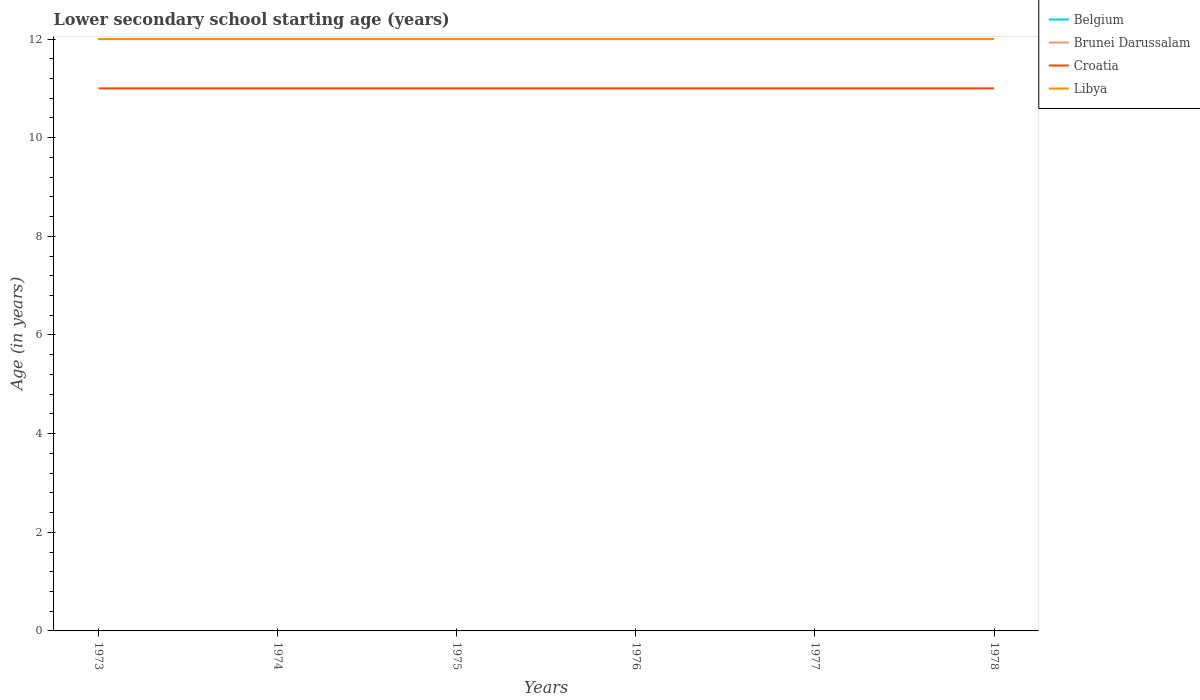Across all years, what is the maximum lower secondary school starting age of children in Belgium?
Your answer should be compact. 12. In which year was the lower secondary school starting age of children in Croatia maximum?
Your answer should be very brief. 1973. What is the total lower secondary school starting age of children in Brunei Darussalam in the graph?
Your answer should be very brief. 0. Is the lower secondary school starting age of children in Brunei Darussalam strictly greater than the lower secondary school starting age of children in Croatia over the years?
Your answer should be very brief. No. Are the values on the major ticks of Y-axis written in scientific E-notation?
Keep it short and to the point. No. Does the graph contain grids?
Provide a succinct answer. No. What is the title of the graph?
Give a very brief answer. Lower secondary school starting age (years). What is the label or title of the X-axis?
Provide a short and direct response. Years. What is the label or title of the Y-axis?
Your answer should be very brief. Age (in years). What is the Age (in years) in Libya in 1973?
Your answer should be very brief. 12. What is the Age (in years) in Belgium in 1975?
Your answer should be compact. 12. What is the Age (in years) of Croatia in 1975?
Your answer should be compact. 11. What is the Age (in years) of Libya in 1975?
Offer a terse response. 12. What is the Age (in years) of Belgium in 1976?
Offer a very short reply. 12. What is the Age (in years) of Libya in 1976?
Give a very brief answer. 12. What is the Age (in years) in Brunei Darussalam in 1977?
Provide a succinct answer. 12. What is the Age (in years) of Croatia in 1977?
Provide a succinct answer. 11. What is the Age (in years) in Brunei Darussalam in 1978?
Make the answer very short. 12. What is the Age (in years) of Croatia in 1978?
Your answer should be very brief. 11. Across all years, what is the maximum Age (in years) of Brunei Darussalam?
Provide a succinct answer. 12. Across all years, what is the minimum Age (in years) in Belgium?
Keep it short and to the point. 12. Across all years, what is the minimum Age (in years) of Brunei Darussalam?
Offer a very short reply. 12. Across all years, what is the minimum Age (in years) in Croatia?
Provide a short and direct response. 11. Across all years, what is the minimum Age (in years) in Libya?
Offer a very short reply. 12. What is the total Age (in years) in Belgium in the graph?
Offer a very short reply. 72. What is the total Age (in years) of Croatia in the graph?
Your answer should be compact. 66. What is the total Age (in years) in Libya in the graph?
Give a very brief answer. 72. What is the difference between the Age (in years) of Belgium in 1973 and that in 1974?
Provide a succinct answer. 0. What is the difference between the Age (in years) in Croatia in 1973 and that in 1974?
Keep it short and to the point. 0. What is the difference between the Age (in years) in Libya in 1973 and that in 1974?
Provide a short and direct response. 0. What is the difference between the Age (in years) of Belgium in 1973 and that in 1975?
Ensure brevity in your answer.  0. What is the difference between the Age (in years) of Croatia in 1973 and that in 1975?
Give a very brief answer. 0. What is the difference between the Age (in years) of Libya in 1973 and that in 1975?
Offer a very short reply. 0. What is the difference between the Age (in years) in Brunei Darussalam in 1973 and that in 1976?
Keep it short and to the point. 0. What is the difference between the Age (in years) of Croatia in 1973 and that in 1976?
Offer a very short reply. 0. What is the difference between the Age (in years) in Libya in 1973 and that in 1976?
Your response must be concise. 0. What is the difference between the Age (in years) of Brunei Darussalam in 1973 and that in 1977?
Keep it short and to the point. 0. What is the difference between the Age (in years) of Croatia in 1973 and that in 1977?
Offer a terse response. 0. What is the difference between the Age (in years) of Brunei Darussalam in 1973 and that in 1978?
Give a very brief answer. 0. What is the difference between the Age (in years) in Croatia in 1973 and that in 1978?
Your answer should be compact. 0. What is the difference between the Age (in years) in Libya in 1973 and that in 1978?
Provide a succinct answer. 0. What is the difference between the Age (in years) of Belgium in 1974 and that in 1975?
Give a very brief answer. 0. What is the difference between the Age (in years) in Croatia in 1974 and that in 1975?
Offer a very short reply. 0. What is the difference between the Age (in years) of Libya in 1974 and that in 1975?
Offer a terse response. 0. What is the difference between the Age (in years) in Belgium in 1974 and that in 1976?
Ensure brevity in your answer.  0. What is the difference between the Age (in years) in Brunei Darussalam in 1974 and that in 1976?
Your answer should be compact. 0. What is the difference between the Age (in years) in Libya in 1974 and that in 1976?
Your answer should be very brief. 0. What is the difference between the Age (in years) in Belgium in 1974 and that in 1977?
Your answer should be compact. 0. What is the difference between the Age (in years) in Libya in 1974 and that in 1977?
Offer a terse response. 0. What is the difference between the Age (in years) of Belgium in 1974 and that in 1978?
Ensure brevity in your answer.  0. What is the difference between the Age (in years) in Libya in 1974 and that in 1978?
Ensure brevity in your answer.  0. What is the difference between the Age (in years) in Belgium in 1975 and that in 1976?
Make the answer very short. 0. What is the difference between the Age (in years) of Brunei Darussalam in 1975 and that in 1976?
Offer a very short reply. 0. What is the difference between the Age (in years) of Croatia in 1975 and that in 1976?
Offer a very short reply. 0. What is the difference between the Age (in years) of Libya in 1975 and that in 1976?
Your answer should be very brief. 0. What is the difference between the Age (in years) of Brunei Darussalam in 1975 and that in 1977?
Offer a very short reply. 0. What is the difference between the Age (in years) of Croatia in 1975 and that in 1977?
Your answer should be compact. 0. What is the difference between the Age (in years) of Libya in 1975 and that in 1977?
Your answer should be compact. 0. What is the difference between the Age (in years) in Croatia in 1975 and that in 1978?
Your response must be concise. 0. What is the difference between the Age (in years) in Libya in 1975 and that in 1978?
Provide a succinct answer. 0. What is the difference between the Age (in years) in Brunei Darussalam in 1976 and that in 1977?
Keep it short and to the point. 0. What is the difference between the Age (in years) of Belgium in 1976 and that in 1978?
Offer a very short reply. 0. What is the difference between the Age (in years) of Croatia in 1976 and that in 1978?
Provide a succinct answer. 0. What is the difference between the Age (in years) of Libya in 1976 and that in 1978?
Your answer should be compact. 0. What is the difference between the Age (in years) in Brunei Darussalam in 1977 and that in 1978?
Your answer should be very brief. 0. What is the difference between the Age (in years) in Croatia in 1977 and that in 1978?
Offer a very short reply. 0. What is the difference between the Age (in years) in Libya in 1977 and that in 1978?
Keep it short and to the point. 0. What is the difference between the Age (in years) of Belgium in 1973 and the Age (in years) of Croatia in 1974?
Keep it short and to the point. 1. What is the difference between the Age (in years) in Belgium in 1973 and the Age (in years) in Libya in 1974?
Make the answer very short. 0. What is the difference between the Age (in years) of Belgium in 1973 and the Age (in years) of Croatia in 1975?
Your answer should be very brief. 1. What is the difference between the Age (in years) in Brunei Darussalam in 1973 and the Age (in years) in Croatia in 1975?
Ensure brevity in your answer.  1. What is the difference between the Age (in years) of Brunei Darussalam in 1973 and the Age (in years) of Libya in 1975?
Your answer should be very brief. 0. What is the difference between the Age (in years) in Croatia in 1973 and the Age (in years) in Libya in 1975?
Make the answer very short. -1. What is the difference between the Age (in years) in Belgium in 1973 and the Age (in years) in Croatia in 1976?
Offer a terse response. 1. What is the difference between the Age (in years) in Belgium in 1973 and the Age (in years) in Libya in 1976?
Give a very brief answer. 0. What is the difference between the Age (in years) of Brunei Darussalam in 1973 and the Age (in years) of Croatia in 1976?
Ensure brevity in your answer.  1. What is the difference between the Age (in years) of Brunei Darussalam in 1973 and the Age (in years) of Libya in 1977?
Provide a succinct answer. 0. What is the difference between the Age (in years) of Belgium in 1973 and the Age (in years) of Croatia in 1978?
Your answer should be compact. 1. What is the difference between the Age (in years) in Brunei Darussalam in 1973 and the Age (in years) in Croatia in 1978?
Give a very brief answer. 1. What is the difference between the Age (in years) in Brunei Darussalam in 1973 and the Age (in years) in Libya in 1978?
Your answer should be very brief. 0. What is the difference between the Age (in years) of Belgium in 1974 and the Age (in years) of Brunei Darussalam in 1975?
Provide a short and direct response. 0. What is the difference between the Age (in years) in Brunei Darussalam in 1974 and the Age (in years) in Croatia in 1975?
Your answer should be very brief. 1. What is the difference between the Age (in years) of Brunei Darussalam in 1974 and the Age (in years) of Libya in 1975?
Your answer should be compact. 0. What is the difference between the Age (in years) of Croatia in 1974 and the Age (in years) of Libya in 1975?
Keep it short and to the point. -1. What is the difference between the Age (in years) of Belgium in 1974 and the Age (in years) of Libya in 1976?
Give a very brief answer. 0. What is the difference between the Age (in years) in Brunei Darussalam in 1974 and the Age (in years) in Croatia in 1976?
Offer a terse response. 1. What is the difference between the Age (in years) in Belgium in 1974 and the Age (in years) in Brunei Darussalam in 1977?
Your answer should be compact. 0. What is the difference between the Age (in years) of Belgium in 1974 and the Age (in years) of Libya in 1977?
Provide a succinct answer. 0. What is the difference between the Age (in years) of Croatia in 1974 and the Age (in years) of Libya in 1977?
Give a very brief answer. -1. What is the difference between the Age (in years) in Belgium in 1974 and the Age (in years) in Brunei Darussalam in 1978?
Your answer should be compact. 0. What is the difference between the Age (in years) in Belgium in 1974 and the Age (in years) in Libya in 1978?
Make the answer very short. 0. What is the difference between the Age (in years) of Brunei Darussalam in 1974 and the Age (in years) of Libya in 1978?
Offer a terse response. 0. What is the difference between the Age (in years) of Belgium in 1975 and the Age (in years) of Brunei Darussalam in 1976?
Your answer should be very brief. 0. What is the difference between the Age (in years) of Belgium in 1975 and the Age (in years) of Croatia in 1976?
Offer a terse response. 1. What is the difference between the Age (in years) of Brunei Darussalam in 1975 and the Age (in years) of Croatia in 1976?
Keep it short and to the point. 1. What is the difference between the Age (in years) of Brunei Darussalam in 1975 and the Age (in years) of Libya in 1976?
Give a very brief answer. 0. What is the difference between the Age (in years) in Croatia in 1975 and the Age (in years) in Libya in 1976?
Provide a succinct answer. -1. What is the difference between the Age (in years) in Brunei Darussalam in 1975 and the Age (in years) in Libya in 1977?
Your answer should be very brief. 0. What is the difference between the Age (in years) of Croatia in 1975 and the Age (in years) of Libya in 1977?
Keep it short and to the point. -1. What is the difference between the Age (in years) in Belgium in 1975 and the Age (in years) in Libya in 1978?
Make the answer very short. 0. What is the difference between the Age (in years) of Brunei Darussalam in 1975 and the Age (in years) of Libya in 1978?
Provide a succinct answer. 0. What is the difference between the Age (in years) in Croatia in 1975 and the Age (in years) in Libya in 1978?
Give a very brief answer. -1. What is the difference between the Age (in years) in Belgium in 1976 and the Age (in years) in Brunei Darussalam in 1977?
Provide a succinct answer. 0. What is the difference between the Age (in years) in Belgium in 1976 and the Age (in years) in Libya in 1977?
Offer a terse response. 0. What is the difference between the Age (in years) of Belgium in 1976 and the Age (in years) of Brunei Darussalam in 1978?
Offer a terse response. 0. What is the difference between the Age (in years) of Croatia in 1977 and the Age (in years) of Libya in 1978?
Ensure brevity in your answer.  -1. What is the average Age (in years) in Brunei Darussalam per year?
Provide a short and direct response. 12. What is the average Age (in years) of Croatia per year?
Make the answer very short. 11. What is the average Age (in years) of Libya per year?
Give a very brief answer. 12. In the year 1973, what is the difference between the Age (in years) of Belgium and Age (in years) of Libya?
Provide a succinct answer. 0. In the year 1973, what is the difference between the Age (in years) of Brunei Darussalam and Age (in years) of Croatia?
Offer a very short reply. 1. In the year 1973, what is the difference between the Age (in years) of Brunei Darussalam and Age (in years) of Libya?
Your response must be concise. 0. In the year 1974, what is the difference between the Age (in years) of Belgium and Age (in years) of Croatia?
Provide a succinct answer. 1. In the year 1974, what is the difference between the Age (in years) in Belgium and Age (in years) in Libya?
Offer a very short reply. 0. In the year 1974, what is the difference between the Age (in years) in Brunei Darussalam and Age (in years) in Libya?
Your answer should be compact. 0. In the year 1974, what is the difference between the Age (in years) in Croatia and Age (in years) in Libya?
Ensure brevity in your answer.  -1. In the year 1975, what is the difference between the Age (in years) in Belgium and Age (in years) in Croatia?
Keep it short and to the point. 1. In the year 1976, what is the difference between the Age (in years) of Belgium and Age (in years) of Brunei Darussalam?
Provide a short and direct response. 0. In the year 1976, what is the difference between the Age (in years) in Belgium and Age (in years) in Croatia?
Your answer should be very brief. 1. In the year 1977, what is the difference between the Age (in years) in Belgium and Age (in years) in Brunei Darussalam?
Provide a succinct answer. 0. In the year 1977, what is the difference between the Age (in years) in Brunei Darussalam and Age (in years) in Croatia?
Ensure brevity in your answer.  1. In the year 1977, what is the difference between the Age (in years) in Brunei Darussalam and Age (in years) in Libya?
Keep it short and to the point. 0. In the year 1977, what is the difference between the Age (in years) of Croatia and Age (in years) of Libya?
Ensure brevity in your answer.  -1. In the year 1978, what is the difference between the Age (in years) of Belgium and Age (in years) of Brunei Darussalam?
Ensure brevity in your answer.  0. In the year 1978, what is the difference between the Age (in years) in Brunei Darussalam and Age (in years) in Libya?
Your answer should be very brief. 0. In the year 1978, what is the difference between the Age (in years) in Croatia and Age (in years) in Libya?
Your answer should be very brief. -1. What is the ratio of the Age (in years) of Brunei Darussalam in 1973 to that in 1974?
Keep it short and to the point. 1. What is the ratio of the Age (in years) in Belgium in 1973 to that in 1975?
Provide a succinct answer. 1. What is the ratio of the Age (in years) in Brunei Darussalam in 1973 to that in 1975?
Provide a succinct answer. 1. What is the ratio of the Age (in years) in Libya in 1973 to that in 1975?
Your response must be concise. 1. What is the ratio of the Age (in years) of Croatia in 1973 to that in 1976?
Ensure brevity in your answer.  1. What is the ratio of the Age (in years) in Libya in 1973 to that in 1976?
Keep it short and to the point. 1. What is the ratio of the Age (in years) in Brunei Darussalam in 1973 to that in 1977?
Provide a succinct answer. 1. What is the ratio of the Age (in years) of Croatia in 1973 to that in 1977?
Offer a terse response. 1. What is the ratio of the Age (in years) in Libya in 1973 to that in 1977?
Keep it short and to the point. 1. What is the ratio of the Age (in years) of Belgium in 1973 to that in 1978?
Give a very brief answer. 1. What is the ratio of the Age (in years) of Croatia in 1973 to that in 1978?
Make the answer very short. 1. What is the ratio of the Age (in years) of Belgium in 1974 to that in 1975?
Provide a succinct answer. 1. What is the ratio of the Age (in years) of Brunei Darussalam in 1974 to that in 1975?
Your answer should be compact. 1. What is the ratio of the Age (in years) of Croatia in 1974 to that in 1975?
Offer a terse response. 1. What is the ratio of the Age (in years) of Libya in 1974 to that in 1975?
Offer a very short reply. 1. What is the ratio of the Age (in years) in Libya in 1974 to that in 1976?
Keep it short and to the point. 1. What is the ratio of the Age (in years) in Brunei Darussalam in 1974 to that in 1977?
Offer a terse response. 1. What is the ratio of the Age (in years) of Croatia in 1974 to that in 1977?
Your response must be concise. 1. What is the ratio of the Age (in years) of Belgium in 1974 to that in 1978?
Ensure brevity in your answer.  1. What is the ratio of the Age (in years) of Libya in 1974 to that in 1978?
Provide a short and direct response. 1. What is the ratio of the Age (in years) of Belgium in 1975 to that in 1976?
Offer a very short reply. 1. What is the ratio of the Age (in years) in Libya in 1975 to that in 1976?
Make the answer very short. 1. What is the ratio of the Age (in years) in Brunei Darussalam in 1975 to that in 1977?
Provide a short and direct response. 1. What is the ratio of the Age (in years) of Croatia in 1975 to that in 1977?
Keep it short and to the point. 1. What is the ratio of the Age (in years) of Libya in 1975 to that in 1978?
Ensure brevity in your answer.  1. What is the ratio of the Age (in years) in Brunei Darussalam in 1976 to that in 1977?
Offer a very short reply. 1. What is the ratio of the Age (in years) of Croatia in 1976 to that in 1977?
Provide a short and direct response. 1. What is the ratio of the Age (in years) of Brunei Darussalam in 1976 to that in 1978?
Your answer should be very brief. 1. What is the ratio of the Age (in years) of Brunei Darussalam in 1977 to that in 1978?
Provide a short and direct response. 1. What is the ratio of the Age (in years) in Croatia in 1977 to that in 1978?
Offer a terse response. 1. What is the ratio of the Age (in years) of Libya in 1977 to that in 1978?
Ensure brevity in your answer.  1. What is the difference between the highest and the second highest Age (in years) in Belgium?
Provide a short and direct response. 0. What is the difference between the highest and the second highest Age (in years) in Libya?
Offer a terse response. 0. What is the difference between the highest and the lowest Age (in years) in Belgium?
Give a very brief answer. 0. What is the difference between the highest and the lowest Age (in years) in Brunei Darussalam?
Give a very brief answer. 0. What is the difference between the highest and the lowest Age (in years) in Croatia?
Offer a terse response. 0. What is the difference between the highest and the lowest Age (in years) in Libya?
Offer a terse response. 0. 